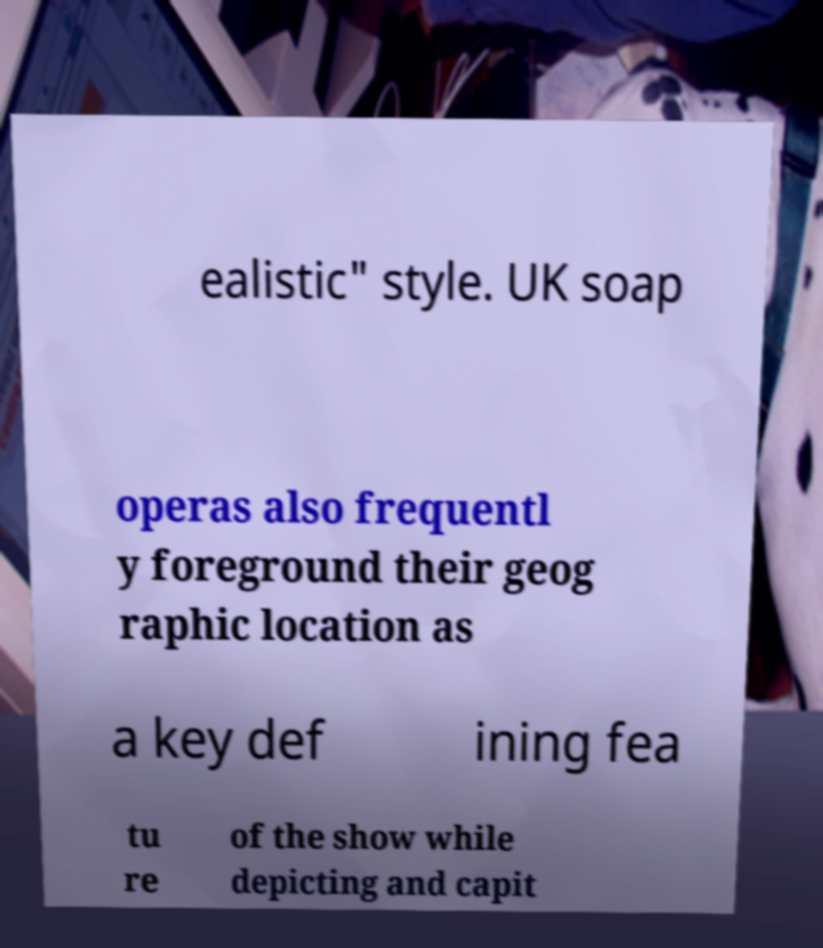Could you extract and type out the text from this image? ealistic" style. UK soap operas also frequentl y foreground their geog raphic location as a key def ining fea tu re of the show while depicting and capit 